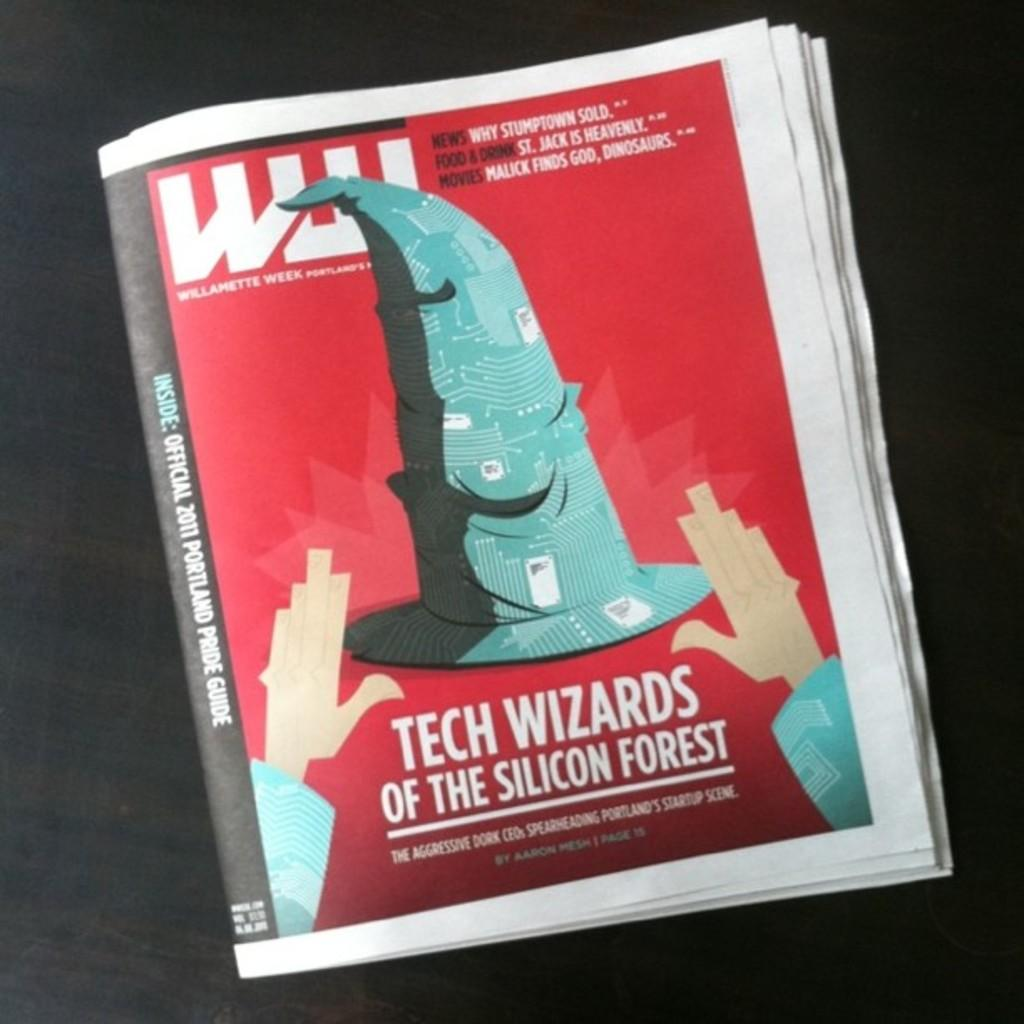<image>
Describe the image concisely. Cover of a booklet named "Tech Wizards of The Silicon Forest" with a wizard hat on it. 